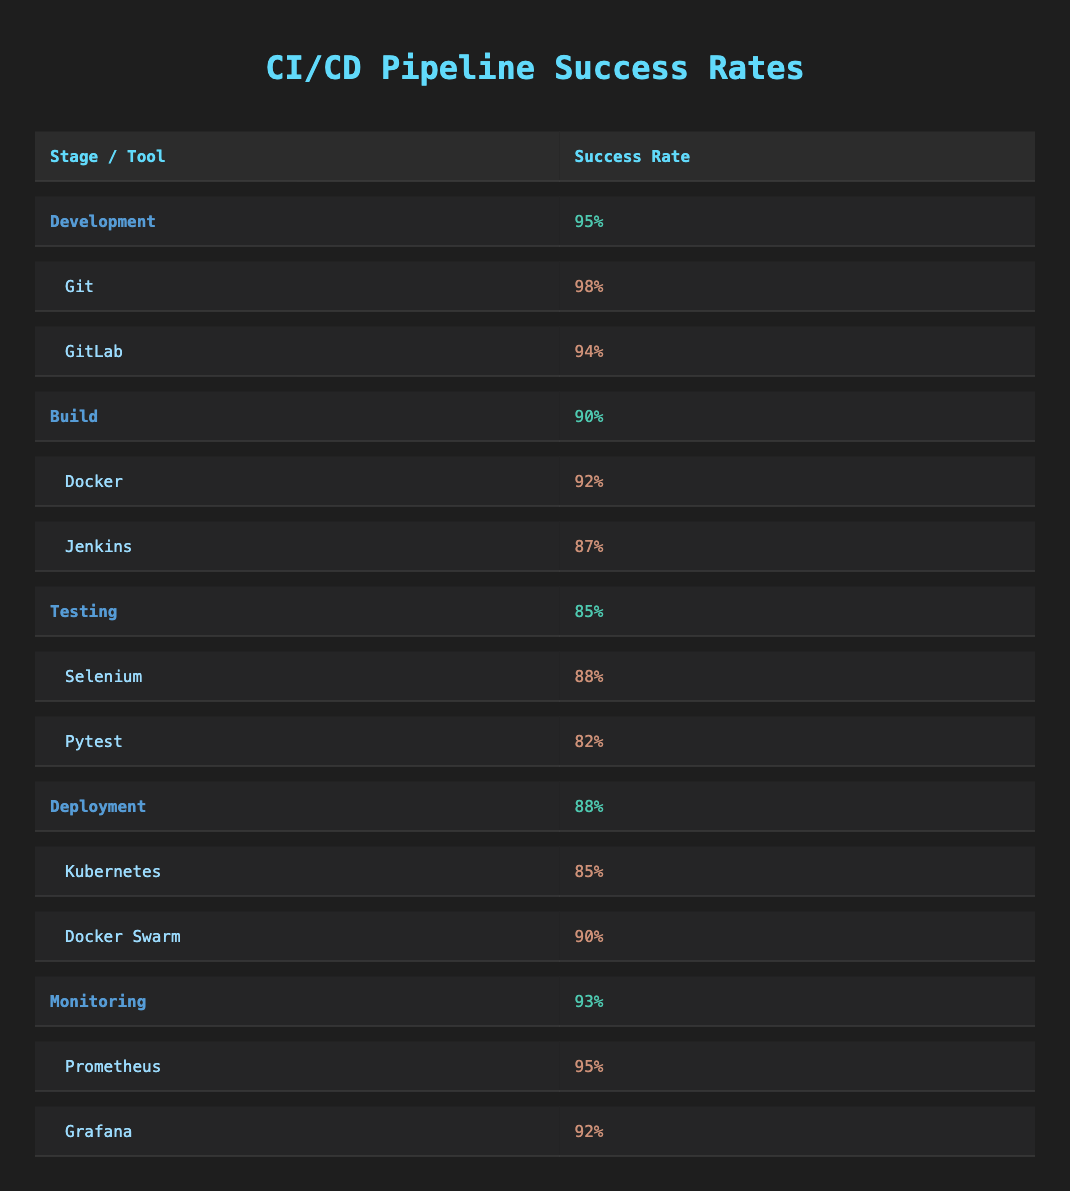What is the success rate for the Build stage? The success rate for the Build stage is listed directly in the table under the corresponding row. It shows a success rate of 90%.
Answer: 90% Which tool has the highest success rate in the Development stage? Looking at the Development stage tools, Git has a success rate of 98%, while GitLab has 94%. Therefore, Git has the highest success rate in this stage.
Answer: Git What is the average success rate for all the stages listed in the table? To calculate the average, we sum the success rates for all the stages: (95 + 90 + 85 + 88 + 93) = 451. There are 5 stages, so the average is 451/5 = 90.2%.
Answer: 90.2% Is the success rate for Docker Swarm higher than that of Kubernetes? The success rate for Docker Swarm is 90% while for Kubernetes it is 85%. Since 90% is greater than 85%, the statement is true.
Answer: Yes What is the difference in success rates between the Testing stage and the Monitoring stage? The success rate for Testing is 85%, and for Monitoring, it is 93%. To find the difference, we subtract: 93 - 85 = 8. Thus, the difference is 8%.
Answer: 8% Which testing tool has a higher success rate, Selenium or Pytest? The table indicates that Selenium has a success rate of 88%, while Pytest has 82%. Consequently, Selenium has the higher success rate in the Testing stage.
Answer: Selenium Is the combined success rate of both tools in the Deployment stage greater than 175%? The success rates for the Deployment tools are Kubernetes at 85% and Docker Swarm at 90%. Adding these gives 85 + 90 = 175%. Since 175% is not greater than 175%, the answer is no.
Answer: No What is the success rate of the lowest tool in the Testing stage? In the Testing stage, Pytest has the lowest success rate of 82% compared to Selenium’s 88%. Therefore, the answer is 82%.
Answer: 82% If we consider only the tools listed, which tool among them has the lowest success rate? By examining the success rates of all tools listed: Git (98%), GitLab (94%), Docker (92%), Jenkins (87%), Selenium (88%), Pytest (82%), Kubernetes (85%), Docker Swarm (90%), Prometheus (95%), and Grafana (92%), we see that Pytest has the lowest at 82%.
Answer: Pytest 